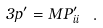Convert formula to latex. <formula><loc_0><loc_0><loc_500><loc_500>3 p ^ { \prime } = M P ^ { \prime } _ { i i } \ .</formula> 